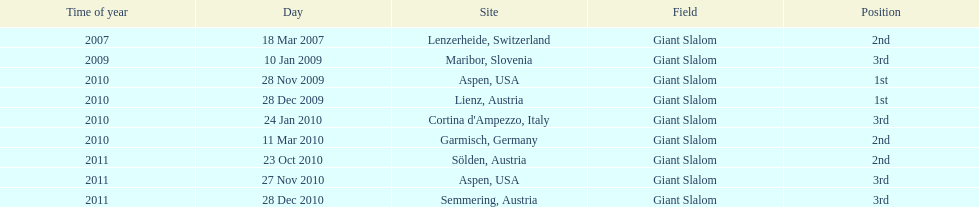What is the total number of her 2nd place finishes on the list? 3. 